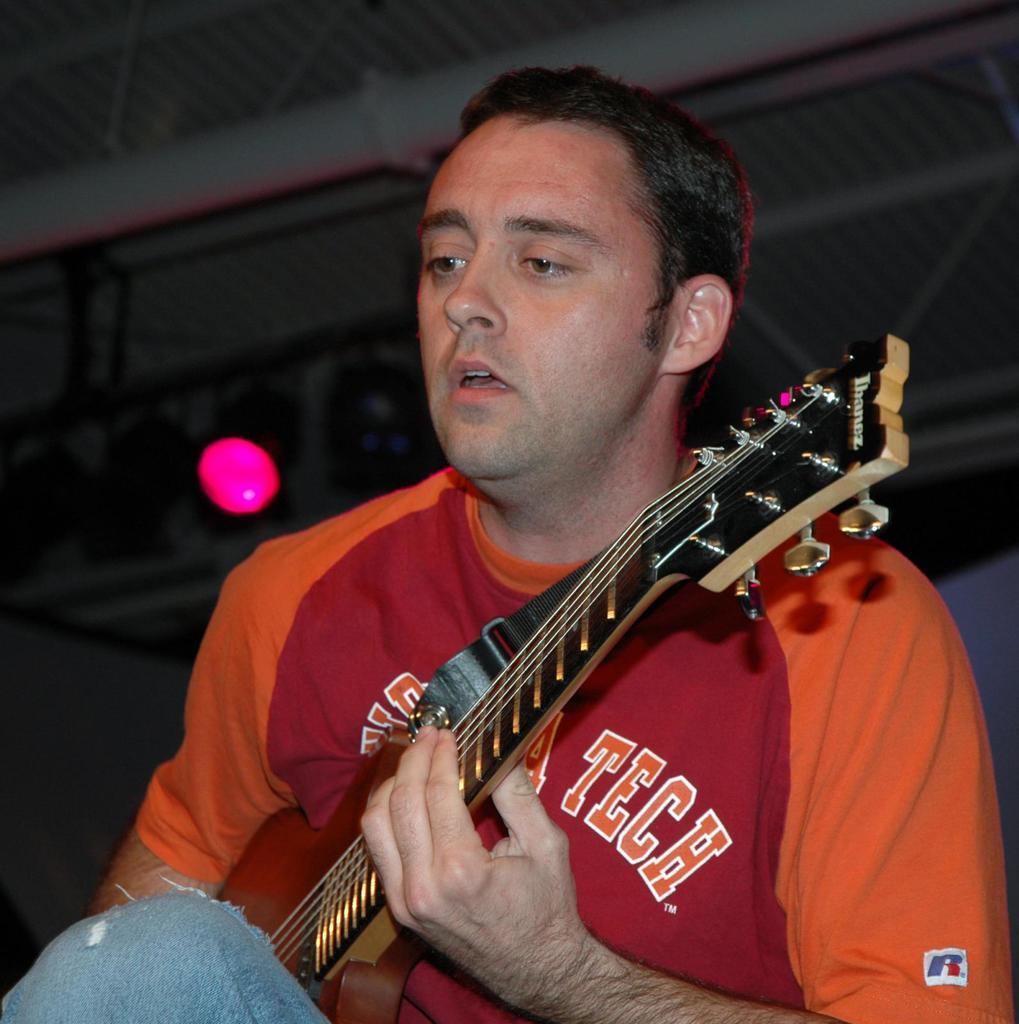In one or two sentences, can you explain what this image depicts? The person wearing orange and red T-shirt is playing a guitar. 